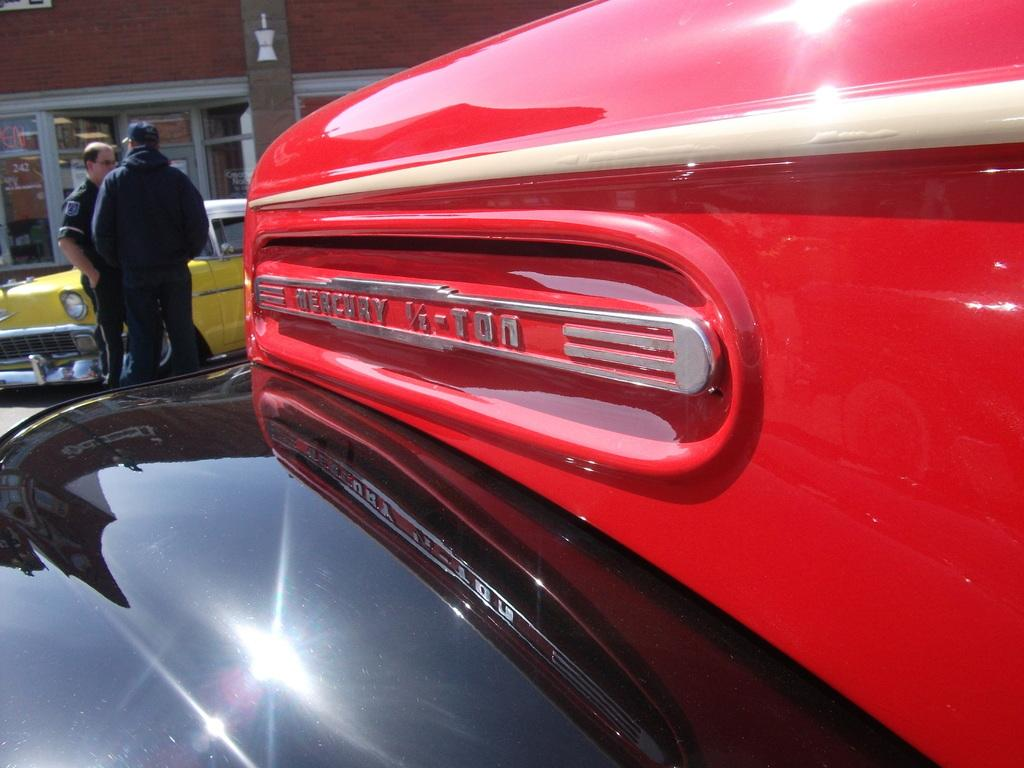<image>
Render a clear and concise summary of the photo. Closeup photo of a red mecury 1/2 ton with two people talking in the background. 